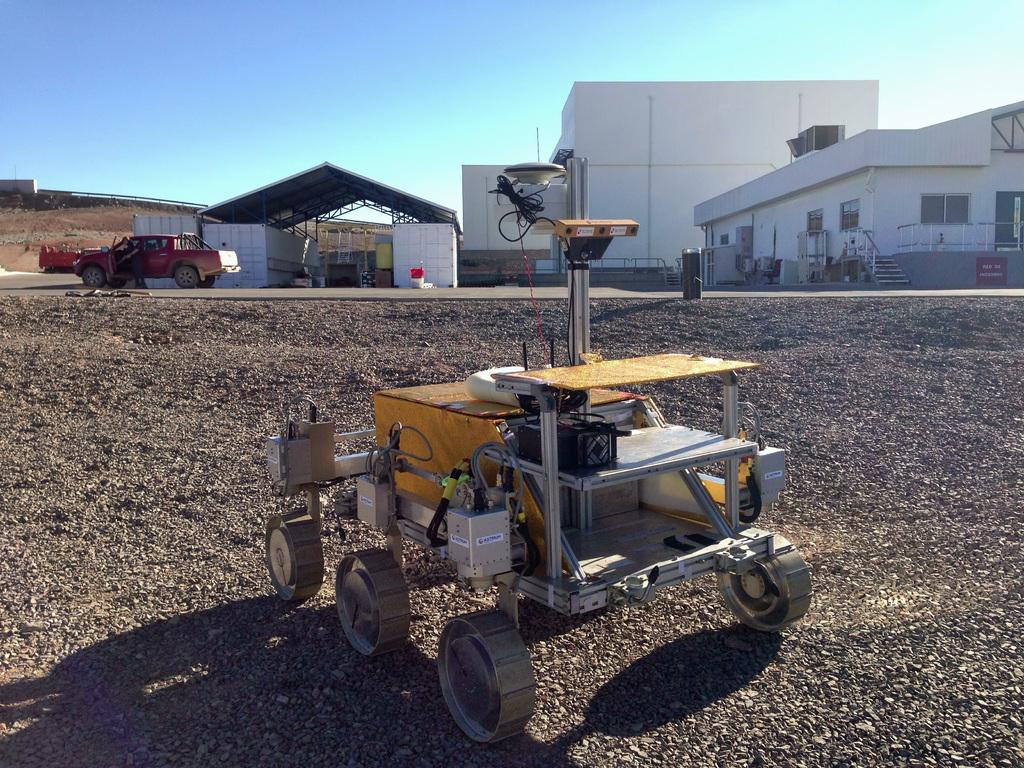What type of vehicle is present in the image? There is a small truck in the image. What is the main subject of the image? The main subject of the image is a machine with wheels. What architectural features can be seen in the image? There are buildings, stairs, windows, and a shelter with a roof visible in the image. What type of coat is being worn by the question in the image? There is no person wearing a coat in the image, as the provided facts do not mention any individuals. 